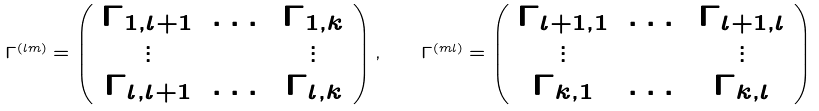Convert formula to latex. <formula><loc_0><loc_0><loc_500><loc_500>\Gamma ^ { ( l m ) } = \left ( \begin{array} { c c c } \Gamma _ { 1 , l + 1 } & \dots & \Gamma _ { 1 , k } \\ \vdots & & \vdots \\ \Gamma _ { l , l + 1 } & \dots & \Gamma _ { l , k } \\ \end{array} \right ) , \quad \Gamma ^ { ( m l ) } = \left ( \begin{array} { c c c c } \Gamma _ { l + 1 , 1 } & \dots & \Gamma _ { l + 1 , l } \\ \vdots & & \vdots \\ \Gamma _ { k , 1 } & \dots & \Gamma _ { k , l } \\ \end{array} \right )</formula> 